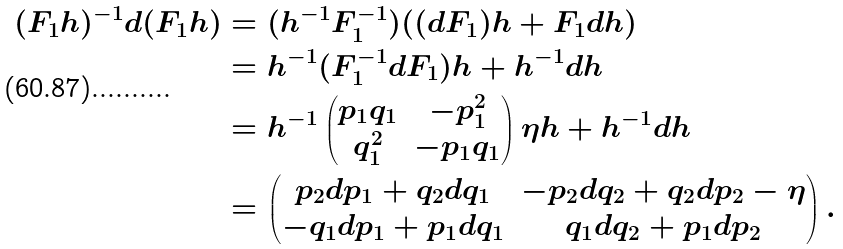<formula> <loc_0><loc_0><loc_500><loc_500>( F _ { 1 } h ) ^ { - 1 } d ( F _ { 1 } h ) & = ( h ^ { - 1 } F _ { 1 } ^ { - 1 } ) ( ( d F _ { 1 } ) h + F _ { 1 } d h ) \\ & = h ^ { - 1 } ( F _ { 1 } ^ { - 1 } d F _ { 1 } ) h + h ^ { - 1 } d h \\ & = h ^ { - 1 } \begin{pmatrix} p _ { 1 } q _ { 1 } & - p _ { 1 } ^ { 2 } \\ q _ { 1 } ^ { 2 } & - p _ { 1 } q _ { 1 } \end{pmatrix} \eta h + h ^ { - 1 } d h \\ & = \begin{pmatrix} p _ { 2 } d p _ { 1 } + q _ { 2 } d q _ { 1 } & - p _ { 2 } d q _ { 2 } + q _ { 2 } d p _ { 2 } - \eta \\ - q _ { 1 } d p _ { 1 } + p _ { 1 } d q _ { 1 } & q _ { 1 } d q _ { 2 } + p _ { 1 } d p _ { 2 } \end{pmatrix} .</formula> 